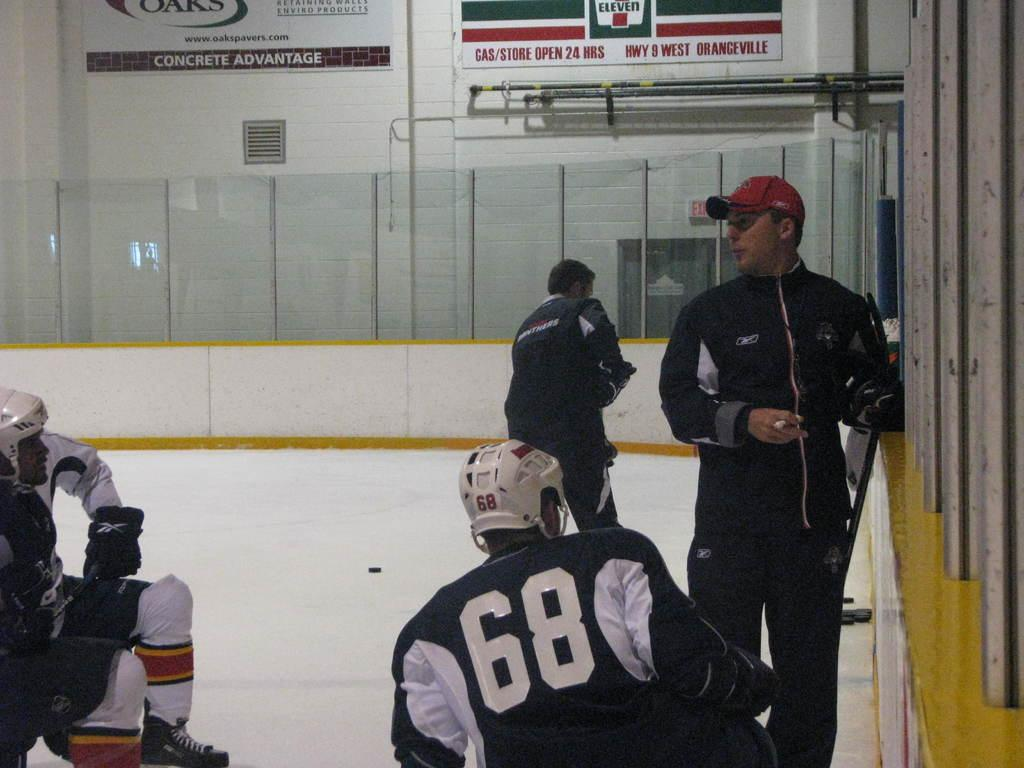<image>
Provide a brief description of the given image. A hockey ring with a 7 11 ad in the background 